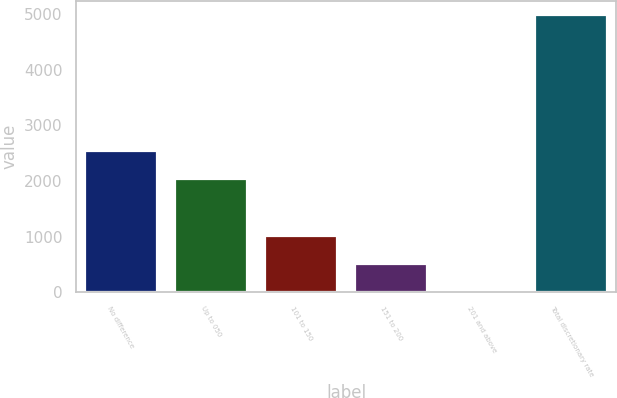<chart> <loc_0><loc_0><loc_500><loc_500><bar_chart><fcel>No difference<fcel>Up to 050<fcel>101 to 150<fcel>151 to 200<fcel>201 and above<fcel>Total discretionary rate<nl><fcel>2537.83<fcel>2039.9<fcel>1002.36<fcel>504.43<fcel>6.5<fcel>4985.8<nl></chart> 